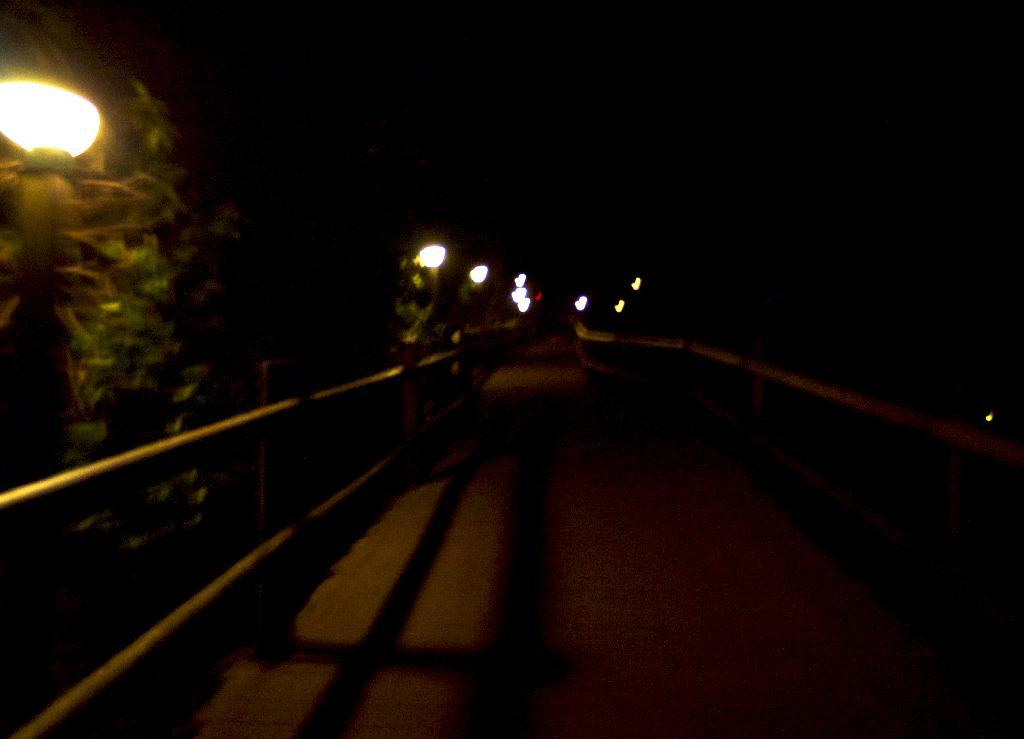What type of barrier is present on the path in the image? There is fencing on the path in the image. What can be seen providing illumination in the image? There are lights visible in the image. What type of vegetation is present in the image? There are trees in the image. Where is the kettle located in the image? There is no kettle present in the image. On which side of the path is the fencing located? The fencing is located on the path itself, not on a specific side. 